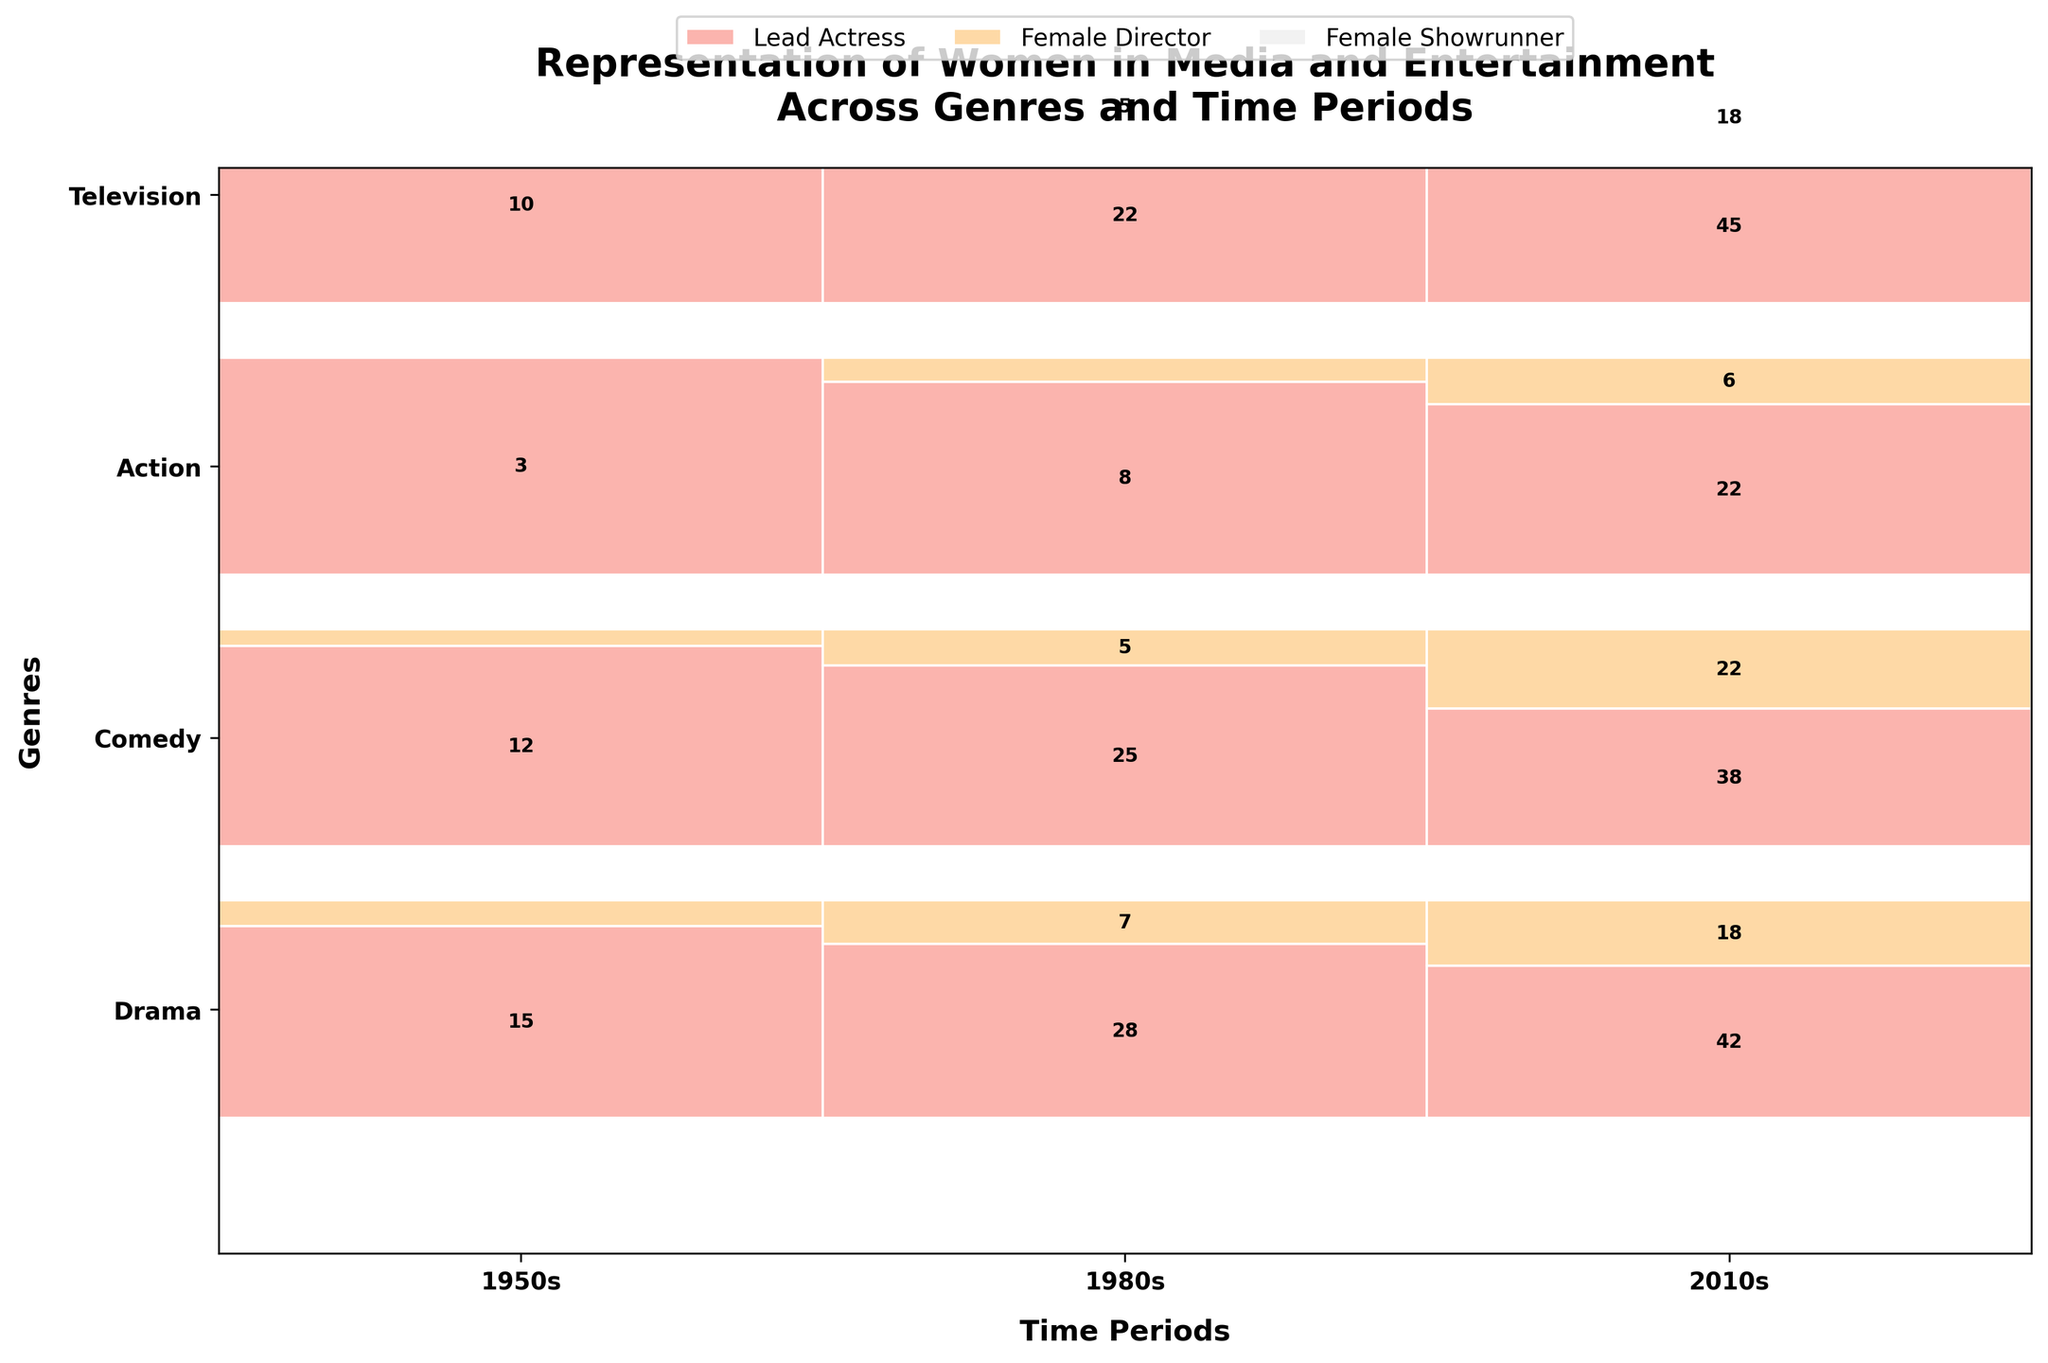What is the title of the mosaic plot? The title is usually at the top of the plot and specifies what the information in the plot is about. Here, it states: "Representation of Women in Media and Entertainment Across Genres and Time Periods".
Answer: Representation of Women in Media and Entertainment Across Genres and Time Periods Which genre shows the most significant increase in lead actresses from the 1950s to the 2010s? To find this, compare the number of lead actresses in each genre between the 1950s and the 2010s. For example, Drama went from 15 to 42, Comedy from 12 to 38, and Action from 3 to 22. Drama has the most substantial increase.
Answer: Drama How many female directors were there in Comedy in the 1980s and 2010s combined? Add the counts of female directors in Comedy for these two periods: 5 in the 1980s and 22 in the 2010s, so the total is 5 + 22.
Answer: 27 Which time period sees the highest representation of female showrunners in television? Look at the numbers for female showrunners in television across the different periods: 1 in the 1950s, 5 in the 1980s, and 18 in the 2010s. The 2010s have the highest representation.
Answer: 2010s Compare the total number of lead actresses and female directors in the Drama genre in the 2010s. Which role has higher representation? In the Drama genre in the 2010s, there are 42 lead actresses and 18 female directors. Comparing these two numbers, lead actresses have higher representation.
Answer: Lead Actress Which genre has the highest total representation from the 1950s to 2010s across all roles? To find this, sum the counts of all roles in each genre across all time periods. Drama: (15+2)+(28+7)+(42+18), Comedy: (12+1)+(25+5)+(38+22), Action: (3+0)+(8+1)+(22+6), Television: (1+10)+(5+22)+(18+45). Drama: 112, Comedy: 103, Action: 40, Television: 101. Drama has the highest total.
Answer: Drama Which representation category has the lowest count in any genre and time period combination? Look at the smallest numbers across all the categories. The smallest count is 0, which is for Female Directors in Action in the 1950s.
Answer: Female Director in Action in the 1950s In the 2010s, which genre had the closest representation numbers between lead actresses and female directors? Compare the counts in the 2010s for lead actresses and female directors in each genre: Drama (42 vs 18), Comedy (38 vs 22), Action (22 vs 6), Television (45 lead actress, no female directors given). Comedy has the closest numbers, 38 vs 22.
Answer: Comedy How does the number of lead actresses in Action in the 1980s compare to Drama in the same period? Look at the counts for lead actresses: Action has 8 and Drama has 28. Comparing these, Drama has more lead actresses than Action in the 1980s.
Answer: Drama has more 